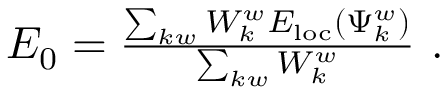Convert formula to latex. <formula><loc_0><loc_0><loc_500><loc_500>\begin{array} { r } { E _ { 0 } = \frac { \sum _ { k w } W _ { k } ^ { w } E _ { l o c } ( \Psi _ { k } ^ { w } ) } { \sum _ { k w } W _ { k } ^ { w } } . } \end{array}</formula> 